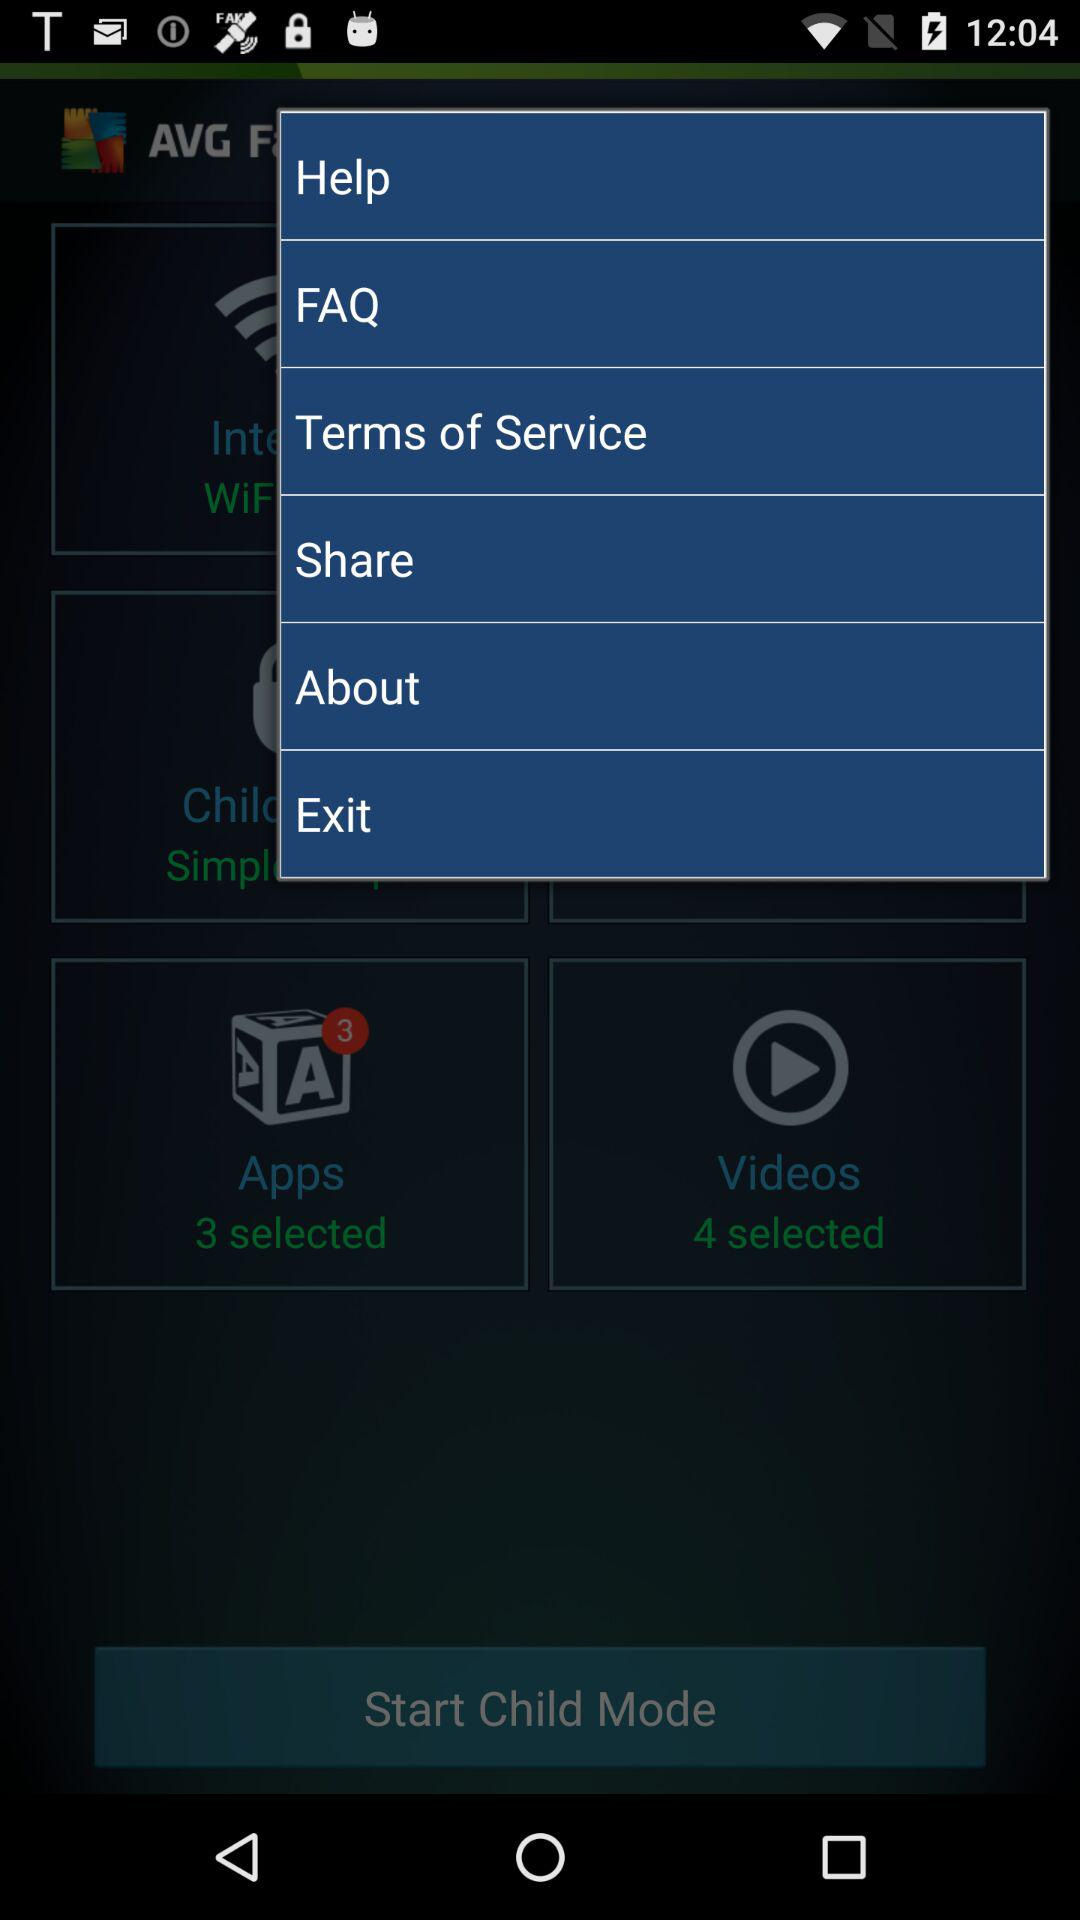What is the number of the selected applications? The number of the selected apps is 3. 